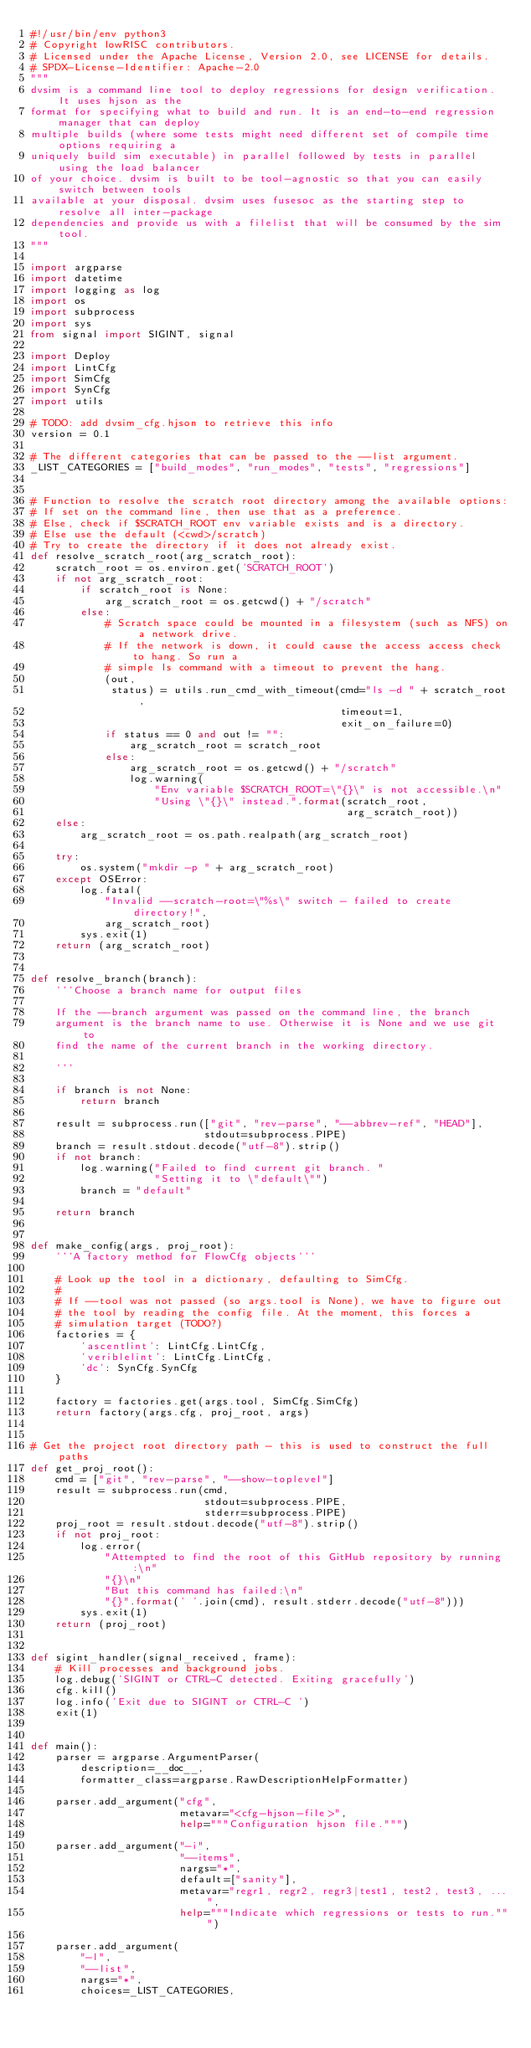<code> <loc_0><loc_0><loc_500><loc_500><_Python_>#!/usr/bin/env python3
# Copyright lowRISC contributors.
# Licensed under the Apache License, Version 2.0, see LICENSE for details.
# SPDX-License-Identifier: Apache-2.0
"""
dvsim is a command line tool to deploy regressions for design verification. It uses hjson as the
format for specifying what to build and run. It is an end-to-end regression manager that can deploy
multiple builds (where some tests might need different set of compile time options requiring a
uniquely build sim executable) in parallel followed by tests in parallel using the load balancer
of your choice. dvsim is built to be tool-agnostic so that you can easily switch between tools
available at your disposal. dvsim uses fusesoc as the starting step to resolve all inter-package
dependencies and provide us with a filelist that will be consumed by the sim tool.
"""

import argparse
import datetime
import logging as log
import os
import subprocess
import sys
from signal import SIGINT, signal

import Deploy
import LintCfg
import SimCfg
import SynCfg
import utils

# TODO: add dvsim_cfg.hjson to retrieve this info
version = 0.1

# The different categories that can be passed to the --list argument.
_LIST_CATEGORIES = ["build_modes", "run_modes", "tests", "regressions"]


# Function to resolve the scratch root directory among the available options:
# If set on the command line, then use that as a preference.
# Else, check if $SCRATCH_ROOT env variable exists and is a directory.
# Else use the default (<cwd>/scratch)
# Try to create the directory if it does not already exist.
def resolve_scratch_root(arg_scratch_root):
    scratch_root = os.environ.get('SCRATCH_ROOT')
    if not arg_scratch_root:
        if scratch_root is None:
            arg_scratch_root = os.getcwd() + "/scratch"
        else:
            # Scratch space could be mounted in a filesystem (such as NFS) on a network drive.
            # If the network is down, it could cause the access access check to hang. So run a
            # simple ls command with a timeout to prevent the hang.
            (out,
             status) = utils.run_cmd_with_timeout(cmd="ls -d " + scratch_root,
                                                  timeout=1,
                                                  exit_on_failure=0)
            if status == 0 and out != "":
                arg_scratch_root = scratch_root
            else:
                arg_scratch_root = os.getcwd() + "/scratch"
                log.warning(
                    "Env variable $SCRATCH_ROOT=\"{}\" is not accessible.\n"
                    "Using \"{}\" instead.".format(scratch_root,
                                                   arg_scratch_root))
    else:
        arg_scratch_root = os.path.realpath(arg_scratch_root)

    try:
        os.system("mkdir -p " + arg_scratch_root)
    except OSError:
        log.fatal(
            "Invalid --scratch-root=\"%s\" switch - failed to create directory!",
            arg_scratch_root)
        sys.exit(1)
    return (arg_scratch_root)


def resolve_branch(branch):
    '''Choose a branch name for output files

    If the --branch argument was passed on the command line, the branch
    argument is the branch name to use. Otherwise it is None and we use git to
    find the name of the current branch in the working directory.

    '''

    if branch is not None:
        return branch

    result = subprocess.run(["git", "rev-parse", "--abbrev-ref", "HEAD"],
                            stdout=subprocess.PIPE)
    branch = result.stdout.decode("utf-8").strip()
    if not branch:
        log.warning("Failed to find current git branch. "
                    "Setting it to \"default\"")
        branch = "default"

    return branch


def make_config(args, proj_root):
    '''A factory method for FlowCfg objects'''

    # Look up the tool in a dictionary, defaulting to SimCfg.
    #
    # If --tool was not passed (so args.tool is None), we have to figure out
    # the tool by reading the config file. At the moment, this forces a
    # simulation target (TODO?)
    factories = {
        'ascentlint': LintCfg.LintCfg,
        'veriblelint': LintCfg.LintCfg,
        'dc': SynCfg.SynCfg
    }

    factory = factories.get(args.tool, SimCfg.SimCfg)
    return factory(args.cfg, proj_root, args)


# Get the project root directory path - this is used to construct the full paths
def get_proj_root():
    cmd = ["git", "rev-parse", "--show-toplevel"]
    result = subprocess.run(cmd,
                            stdout=subprocess.PIPE,
                            stderr=subprocess.PIPE)
    proj_root = result.stdout.decode("utf-8").strip()
    if not proj_root:
        log.error(
            "Attempted to find the root of this GitHub repository by running:\n"
            "{}\n"
            "But this command has failed:\n"
            "{}".format(' '.join(cmd), result.stderr.decode("utf-8")))
        sys.exit(1)
    return (proj_root)


def sigint_handler(signal_received, frame):
    # Kill processes and background jobs.
    log.debug('SIGINT or CTRL-C detected. Exiting gracefully')
    cfg.kill()
    log.info('Exit due to SIGINT or CTRL-C ')
    exit(1)


def main():
    parser = argparse.ArgumentParser(
        description=__doc__,
        formatter_class=argparse.RawDescriptionHelpFormatter)

    parser.add_argument("cfg",
                        metavar="<cfg-hjson-file>",
                        help="""Configuration hjson file.""")

    parser.add_argument("-i",
                        "--items",
                        nargs="*",
                        default=["sanity"],
                        metavar="regr1, regr2, regr3|test1, test2, test3, ...",
                        help="""Indicate which regressions or tests to run.""")

    parser.add_argument(
        "-l",
        "--list",
        nargs="*",
        choices=_LIST_CATEGORIES,</code> 